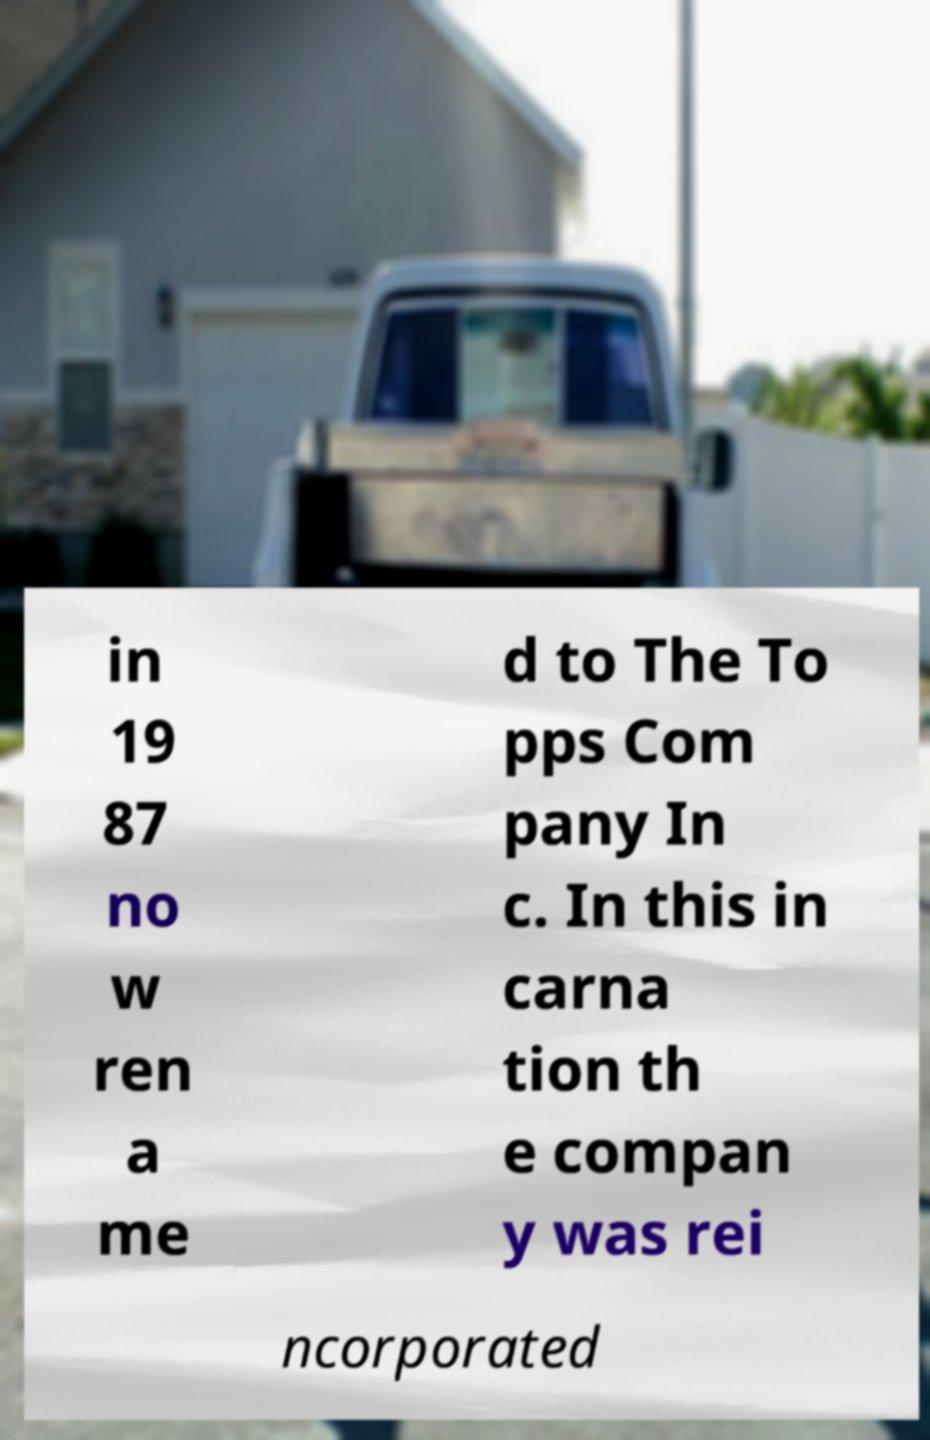For documentation purposes, I need the text within this image transcribed. Could you provide that? in 19 87 no w ren a me d to The To pps Com pany In c. In this in carna tion th e compan y was rei ncorporated 